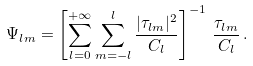<formula> <loc_0><loc_0><loc_500><loc_500>\Psi _ { l m } = \left [ \sum _ { l = 0 } ^ { + \infty } \sum _ { m = - l } ^ { l } \frac { | \tau _ { l m } | ^ { 2 } } { C _ { l } } \right ] ^ { - 1 } \, \frac { \tau _ { l m } } { C _ { l } } \, .</formula> 